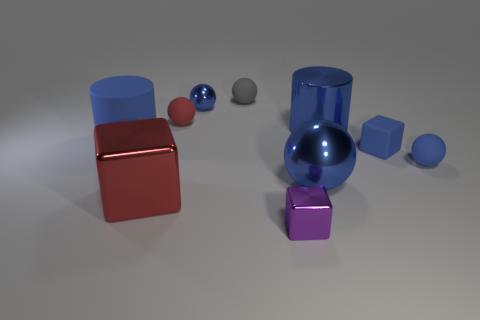Subtract all blue balls. How many were subtracted if there are1blue balls left? 2 Subtract all metallic cubes. How many cubes are left? 1 Subtract all gray balls. How many balls are left? 4 Subtract all cyan cylinders. How many blue balls are left? 3 Subtract 1 blocks. How many blocks are left? 2 Add 1 purple matte balls. How many purple matte balls exist? 1 Subtract 0 brown cubes. How many objects are left? 10 Subtract all cubes. How many objects are left? 7 Subtract all cyan spheres. Subtract all gray cubes. How many spheres are left? 5 Subtract all big balls. Subtract all small blue objects. How many objects are left? 6 